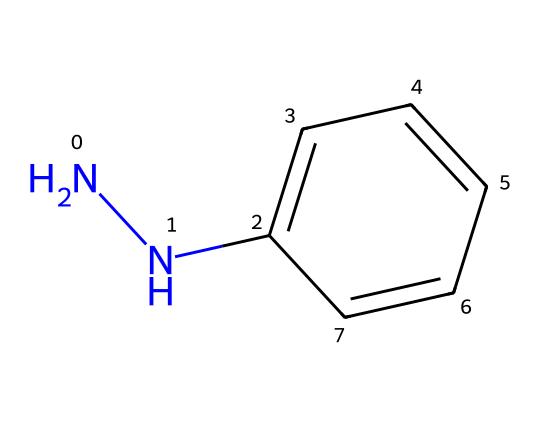What is the molecular formula of phenylhydrazine? To determine the molecular formula, we need to count the carbon, hydrogen, and nitrogen atoms in the structure. There are 6 carbon atoms, 8 hydrogen atoms, and 2 nitrogen atoms. Thus, the molecular formula is C6H8N2.
Answer: C6H8N2 How many rings are present in this chemical structure? By analyzing the structure, there is one ring formed by the six carbon atoms and the hydrogen atoms attached to them. Therefore, there is one ring present.
Answer: 1 What type of functional groups are found in phenylhydrazine? The structure features an amine group (-NH2) and a hydrazine group (N-N). Therefore, the main functional groups in phenylhydrazine are amine and hydrazine.
Answer: amine, hydrazine How many total atoms are in phenylhydrazine? To find the total number of atoms, add the counts of carbon, hydrogen, and nitrogen atoms: 6 (C) + 8 (H) + 2 (N) equals 16 atoms in total.
Answer: 16 Does phenylhydrazine have a conjugated system? The benzene ring in the structure allows for alternating double bonds, making it a conjugated system. Therefore, phenylhydrazine does have a conjugated system.
Answer: yes Is phenylhydrazine a solid, liquid, or gas at room temperature? The physical states of organic compounds at room temperature depend on their molecular weight and structure; phenylhydrazine is a liquid at room temperature.
Answer: liquid 